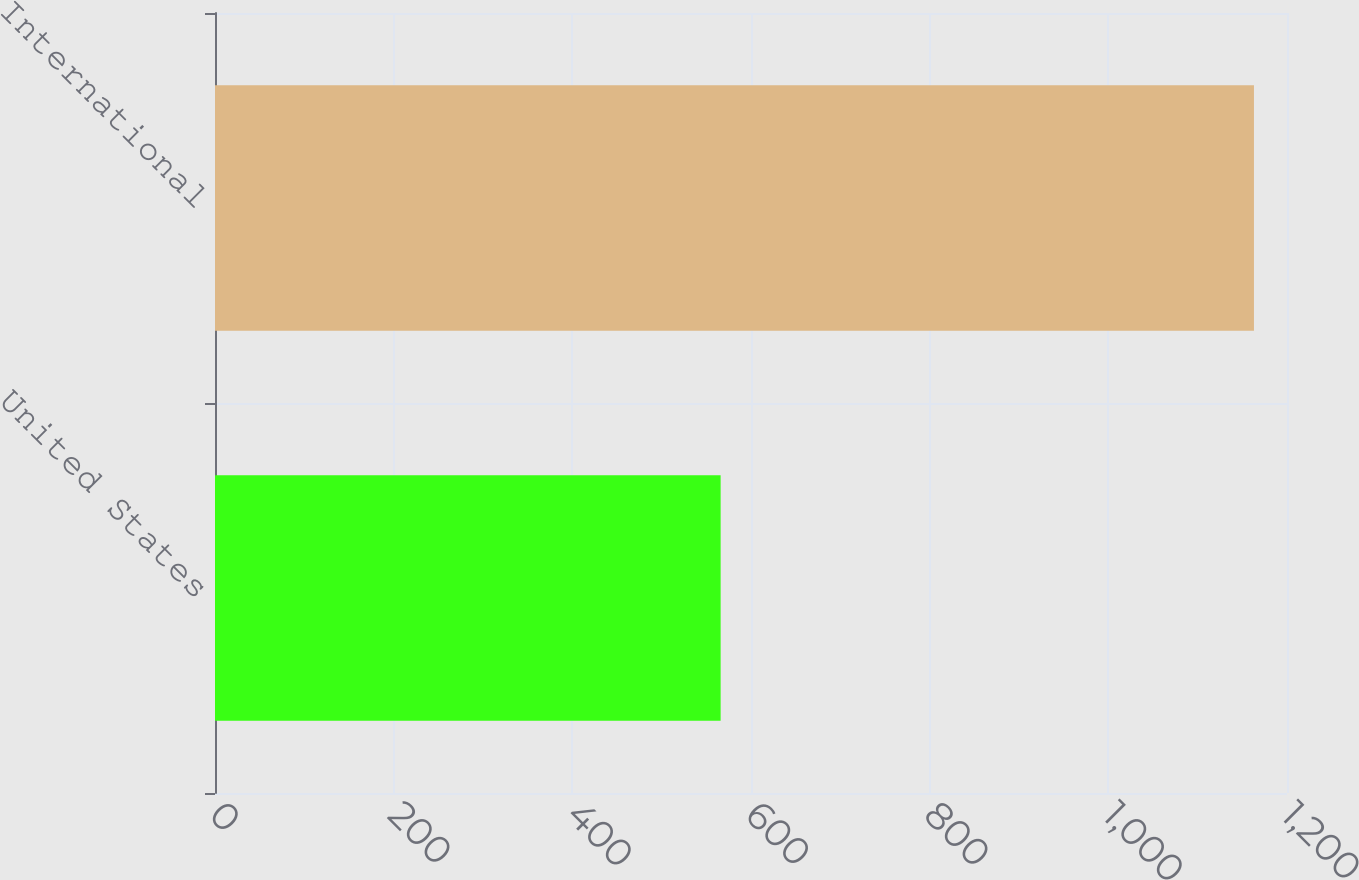Convert chart to OTSL. <chart><loc_0><loc_0><loc_500><loc_500><bar_chart><fcel>United States<fcel>International<nl><fcel>566<fcel>1163<nl></chart> 